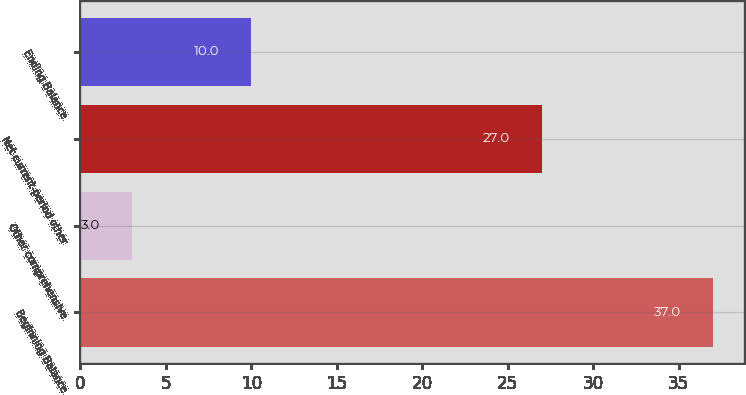<chart> <loc_0><loc_0><loc_500><loc_500><bar_chart><fcel>Beginning Balance<fcel>Other comprehensive<fcel>Net current-period other<fcel>Ending Balance<nl><fcel>37<fcel>3<fcel>27<fcel>10<nl></chart> 